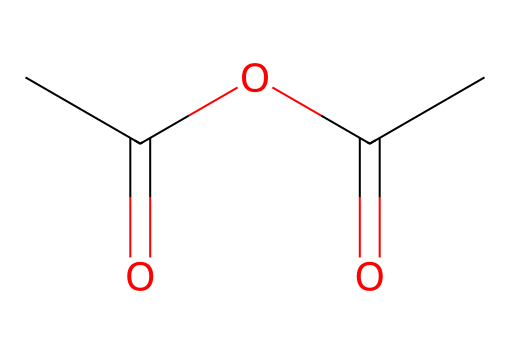What is the name of this chemical? The SMILES representation indicates the chemical consists of two acyl groups linked by an oxygen atom, characteristic of an anhydride. The specific groups present identify it as acetic anhydride.
Answer: acetic anhydride How many carbon atoms are in this structure? By analyzing the SMILES representation, we count four carbon atoms within the formula: two from each acetic acid group and one from the central linkage, making a total of four.
Answer: four How many oxygen atoms are present? Referring to the structure in the SMILES representation, we see a total of three oxygen atoms: one in each acetic acid group and one connecting them, totaling three.
Answer: three What type of functional group is present in this compound? The presence of the ester bond formed between the acyl groups through the oxygen indicates that this is an anhydride, which is a specific type of ester functional group.
Answer: anhydride What is the geometric shape around the carbonyl carbons? The carbonyl carbons in this structure have a trigonal planar configuration due to the double bond with oxygen and the surrounding single bonds, creating an angle of approximately 120 degrees between the substituents.
Answer: trigonal planar What is the significance of the anhydride functional group in synthetic applications? Acid anhydrides, like acetic anhydride, are highly reactive and can facilitate esterification reactions, making them valuable in synthetic processes, particularly for modifying polymers in applications like synthetic grass treatments.
Answer: reactive 